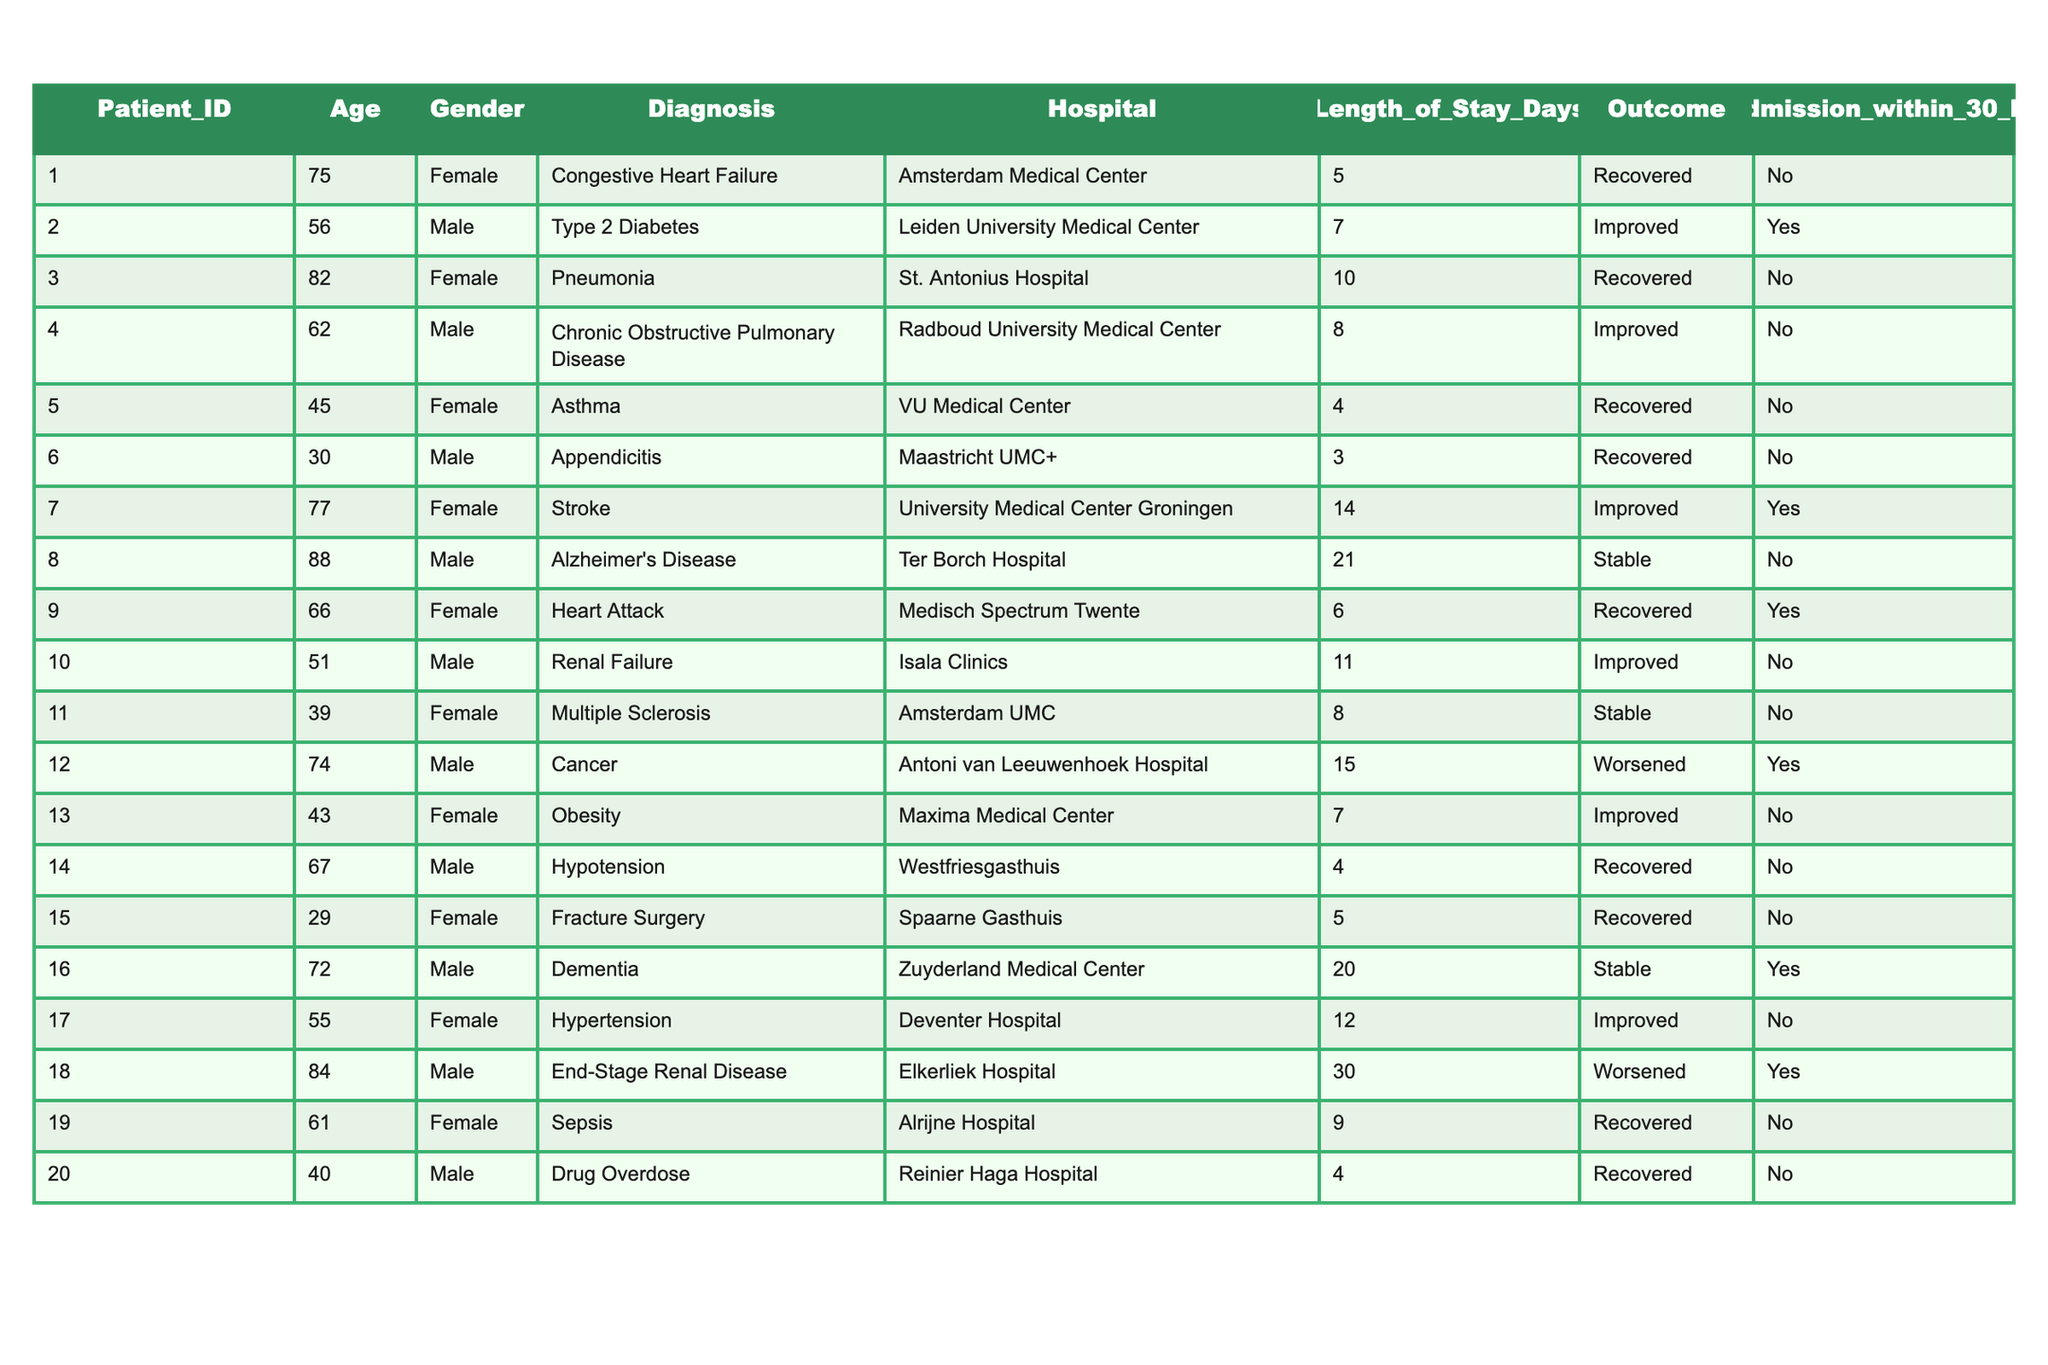What is the average age of female patients in the table? First, we identify the age of all female patients, which are 75, 82, 45, 77, 66, 39, 43, 29, and 55. There are 9 female patients, and we sum their ages (75 + 82 + 45 + 77 + 66 + 39 + 43 + 29 + 55 = 511). Finally, we divide by the number of females: 511 / 9 = approximately 56.78.
Answer: 56.78 How many patients were readmitted within 30 days? We check the "Readmission within 30 Days" column for any recorded "Yes" entries. From our data, the readmissions are observed in patients 2, 7, 12, and 18. Thus, there are a total of 4 readmissions.
Answer: 4 What is the total length of stay for patients diagnosed with cancer? We look for patients diagnosed with cancer and find only one patient (ID 12) with a length of stay of 15 days. Therefore, the total length of stay for cancer patients is simply 15 days.
Answer: 15 Is there any patient in the table diagnosed with Alzheimer's disease? We scan the "Diagnosis" column and find that there is indeed one patient (ID 8) diagnosed with Alzheimer's disease. Therefore, the answer is yes.
Answer: Yes What percentage of patients improved after their treatment? To find the percentage of patients with the "Improved" outcome, we count those outcomes, which are from patients 2, 4, 7, 10, 13, and 17 (6 patients). There are a total of 20 patients, so the percentage is (6/20) * 100 = 30%.
Answer: 30% Which hospital had the longest average length of stay? First, we calculate the average length of stay for each hospital. After calculating: Amsterdam Medical Center (5), Leiden University Medical Center (7), St. Antonius Hospital (10), Radboud University Medical Center (8), VU Medical Center (4), Maastricht UMC+ (3), University Medical Center Groningen (14), Ter Borch Hospital (21), Medisch Spectrum Twente (6), Isala Clinics (11), Amsterdam UMC (8), Antoni van Leeuwenhoek Hospital (15), Maxima Medical Center (7), Westfriesgasthuis (4), Spaarne Gasthuis (5), Zuyderland Medical Center (20), Deventer Hospital (12), Elkerliek Hospital (30), Alrijne Hospital (9), and Reinier Haga Hospital (4). The hospital with the longest stay is Elkerliek Hospital, with an average length of 30 days.
Answer: Elkerliek Hospital How many male patients received an outcome of "Worsened"? We look through the outcomes for male patients. Patient 12 and patient 18 have "Worsened" outcomes. So, there are 2 male patients whose outcomes worsened.
Answer: 2 Was the youngest patient among those treated male or female? We identify the youngest patient by checking the "Age" column. The youngest patient is patient 15, aged 29 and female. Therefore, the youngest patient is female.
Answer: Female What is the count of patients diagnosed with chronic conditions like diabetes and hypertension? We list the patients with chronic conditions; in this case, diabetes (patient 2) and hypertension (patient 17). Hence, the total count is 2 patients.
Answer: 2 Which diagnosis had the highest length of stay reported in the table? We check the "Length of Stay Days" while identifying the diagnosis with the longest stay. The longest stay is for End-Stage Renal Disease with a stay of 30 days (patient 18).
Answer: End-Stage Renal Disease 